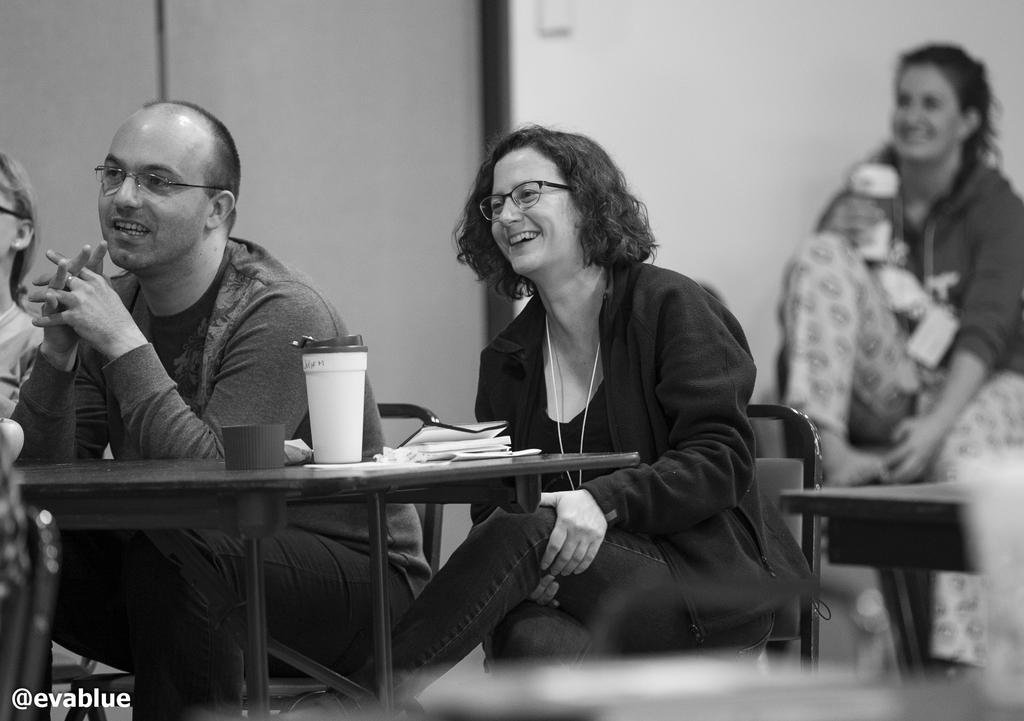How many people are in the image? There are three persons in the image. What are the persons doing in the image? The persons are sitting on a chair and laughing. Can you hear the robin singing in the image? There is no robin or any indication of singing in the image. 